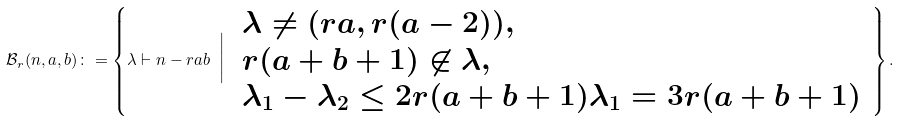Convert formula to latex. <formula><loc_0><loc_0><loc_500><loc_500>\mathcal { B } _ { r } ( n , a , b ) \colon = \left \{ \lambda \vdash n - r a b \ \Big | \ \begin{array} { l } \lambda \neq ( r a , r ( a - 2 ) ) , \\ r ( a + b + 1 ) \not \in \lambda , \\ \lambda _ { 1 } - \lambda _ { 2 } \leq 2 r ( a + b + 1 ) \lambda _ { 1 } = 3 r ( a + b + 1 ) \end{array} \, \right \} .</formula> 